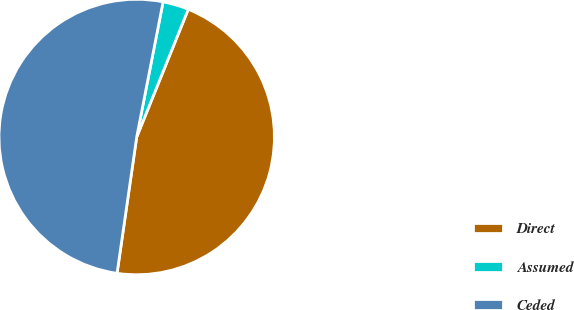Convert chart to OTSL. <chart><loc_0><loc_0><loc_500><loc_500><pie_chart><fcel>Direct<fcel>Assumed<fcel>Ceded<nl><fcel>46.17%<fcel>3.04%<fcel>50.79%<nl></chart> 